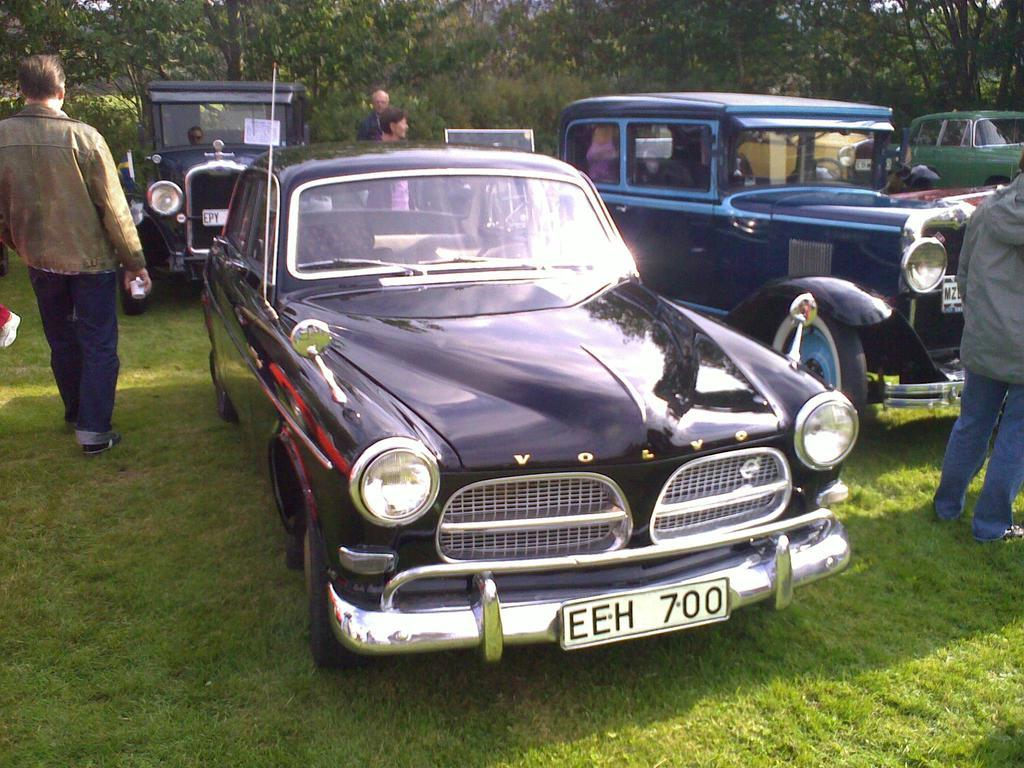What types of objects can be seen in the image? There are vehicles, trees, people, and unspecified objects in the image. What is the terrain like in the image? The land in the image is covered with grass. Can you describe the vegetation in the image? There are trees and grass present in the image. How many types of living organisms can be seen in the image? There are people and trees, which are both living organisms, visible in the image. What type of soap is being used by the people in the image? There is no soap present in the image, as it features vehicles, trees, people, and unspecified objects in a grassy landscape. --- Facts: 1. There is a person in the image. 2. The person is holding a book. 3. The book has a red cover. 4. The person is sitting on a chair. 5. There is a table in the image. Absurd Topics: parrot, ocean, bicycle Conversation: What is the person in the image doing? The person in the image is holding a book. Can you describe the book the person is holding? The book has a red cover. What is the person sitting on in the image? The person is sitting on a chair. What other object can be seen in the image? There is a table in the image. Reasoning: Let's think step by step in order to produce the conversation. We start by identifying the main subject in the image, which is the person holding a book. Then, we expand the conversation to include details about the book, such as its red cover. Next, we mention the person's seating arrangement, which is on a chair. Finally, we acknowledge the presence of another object in the image, which is a table. Absurd Question/Answer: Can you tell me how many parrots are sitting on the bicycle in the image? There are no parrots or bicycles present in the image; it features a person holding a book with a red cover, sitting on a chair, and a table. 